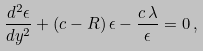Convert formula to latex. <formula><loc_0><loc_0><loc_500><loc_500>\frac { d ^ { 2 } \epsilon } { d y ^ { 2 } } + \left ( c - R \right ) \epsilon - \frac { c \, \lambda } { \epsilon } = 0 \, ,</formula> 